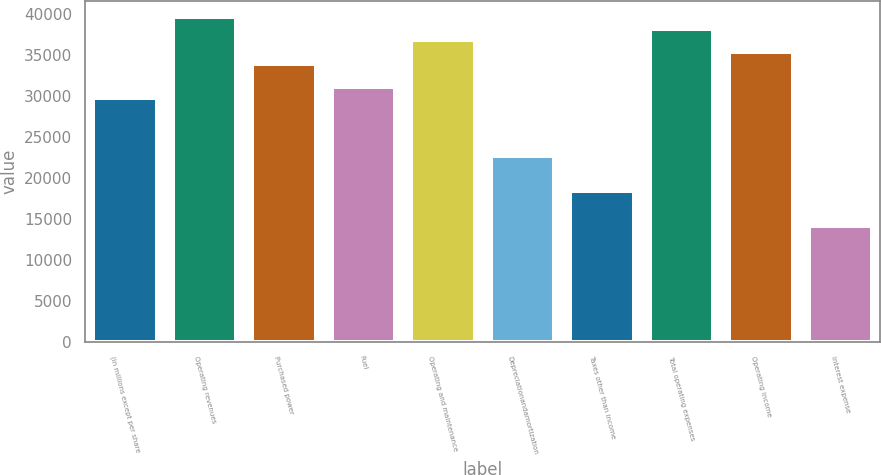<chart> <loc_0><loc_0><loc_500><loc_500><bar_chart><fcel>(in millions except per share<fcel>Operating revenues<fcel>Purchased power<fcel>Fuel<fcel>Operating and maintenance<fcel>Depreciationandamortization<fcel>Taxes other than income<fcel>Total operating expenses<fcel>Operating income<fcel>Interest expense<nl><fcel>29679.3<fcel>39572.4<fcel>33919.2<fcel>31092.6<fcel>36745.8<fcel>22612.8<fcel>18372.9<fcel>38159.1<fcel>35332.5<fcel>14133<nl></chart> 